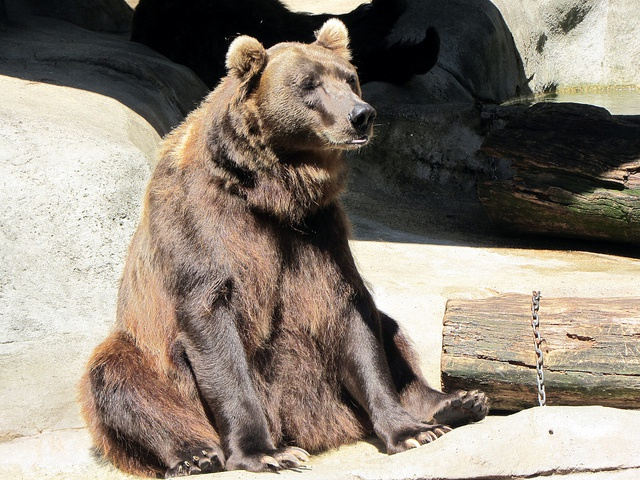Describe the objects in this image and their specific colors. I can see a bear in black, gray, and darkgray tones in this image. 